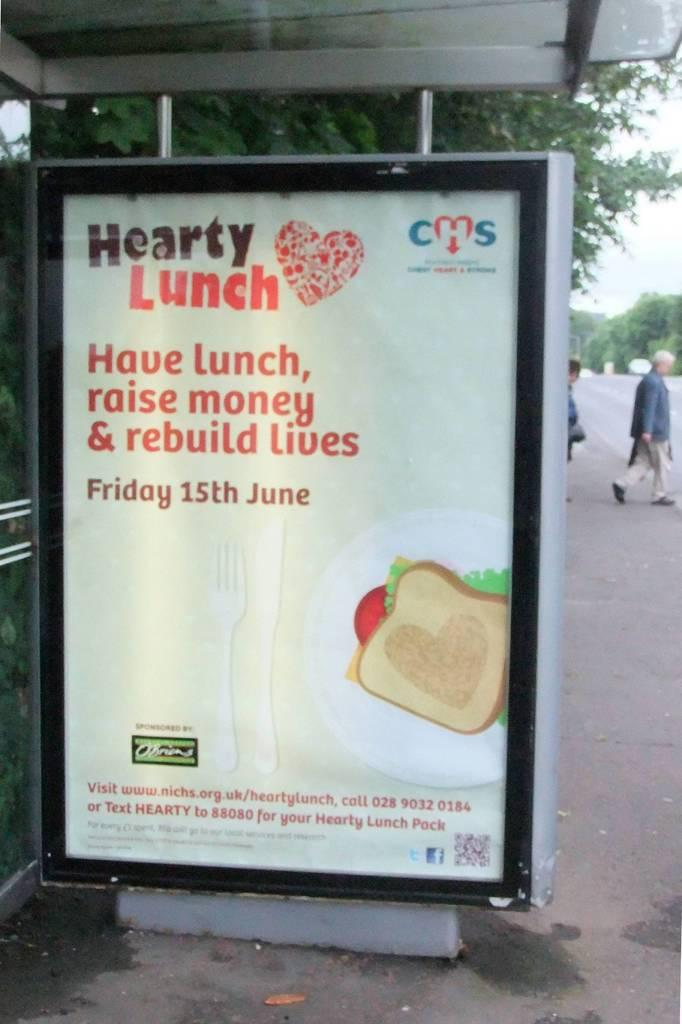<image>
Render a clear and concise summary of the photo. A poster advertising a fundraiser to raise money and rebuild lives that is on Friday, June 15. 